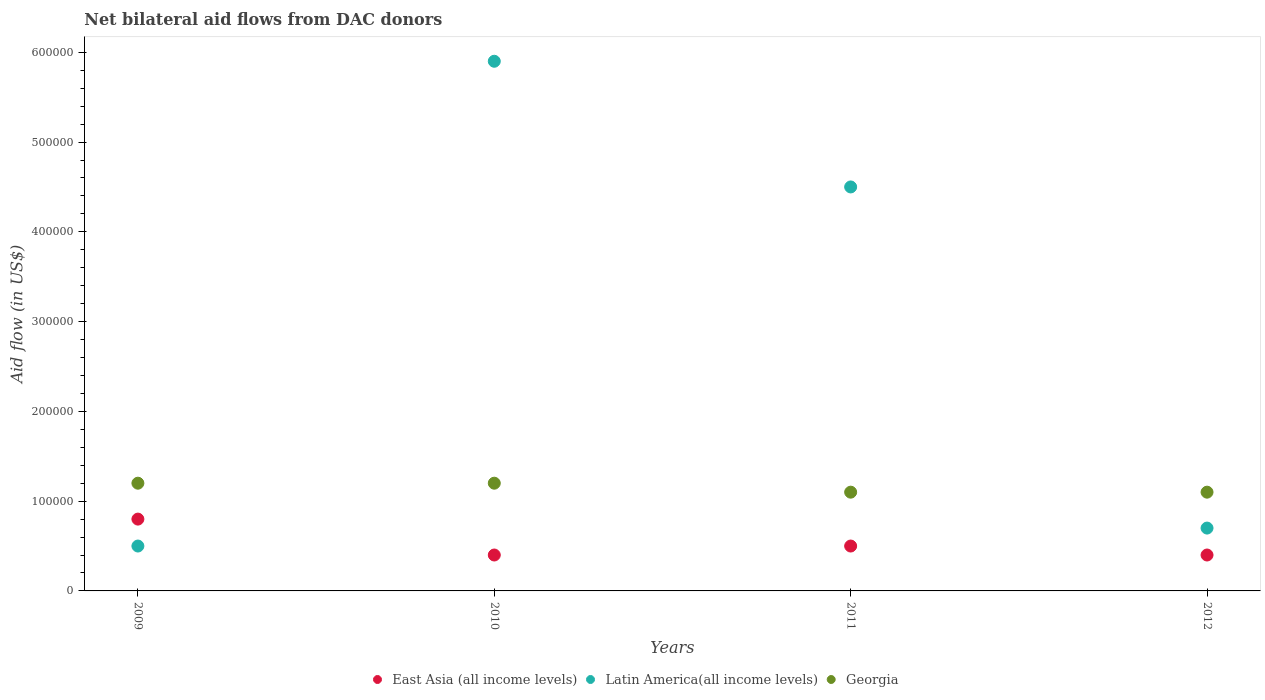What is the net bilateral aid flow in Georgia in 2010?
Give a very brief answer. 1.20e+05. Across all years, what is the maximum net bilateral aid flow in Georgia?
Your answer should be compact. 1.20e+05. Across all years, what is the minimum net bilateral aid flow in East Asia (all income levels)?
Offer a very short reply. 4.00e+04. In which year was the net bilateral aid flow in Latin America(all income levels) minimum?
Offer a very short reply. 2009. What is the total net bilateral aid flow in Latin America(all income levels) in the graph?
Provide a succinct answer. 1.16e+06. What is the difference between the net bilateral aid flow in Georgia in 2010 and that in 2012?
Provide a short and direct response. 10000. What is the difference between the net bilateral aid flow in Georgia in 2009 and the net bilateral aid flow in East Asia (all income levels) in 2010?
Ensure brevity in your answer.  8.00e+04. What is the average net bilateral aid flow in Georgia per year?
Your answer should be very brief. 1.15e+05. In the year 2010, what is the difference between the net bilateral aid flow in East Asia (all income levels) and net bilateral aid flow in Latin America(all income levels)?
Make the answer very short. -5.50e+05. In how many years, is the net bilateral aid flow in Latin America(all income levels) greater than 40000 US$?
Ensure brevity in your answer.  4. Is the net bilateral aid flow in Latin America(all income levels) in 2010 less than that in 2012?
Make the answer very short. No. What is the difference between the highest and the lowest net bilateral aid flow in Georgia?
Make the answer very short. 10000. Does the net bilateral aid flow in East Asia (all income levels) monotonically increase over the years?
Keep it short and to the point. No. Is the net bilateral aid flow in Latin America(all income levels) strictly greater than the net bilateral aid flow in Georgia over the years?
Offer a very short reply. No. Is the net bilateral aid flow in East Asia (all income levels) strictly less than the net bilateral aid flow in Latin America(all income levels) over the years?
Provide a short and direct response. No. How many years are there in the graph?
Provide a succinct answer. 4. What is the difference between two consecutive major ticks on the Y-axis?
Make the answer very short. 1.00e+05. Are the values on the major ticks of Y-axis written in scientific E-notation?
Offer a terse response. No. Does the graph contain any zero values?
Offer a very short reply. No. Does the graph contain grids?
Your answer should be very brief. No. Where does the legend appear in the graph?
Provide a succinct answer. Bottom center. How are the legend labels stacked?
Keep it short and to the point. Horizontal. What is the title of the graph?
Provide a succinct answer. Net bilateral aid flows from DAC donors. Does "Bermuda" appear as one of the legend labels in the graph?
Provide a short and direct response. No. What is the label or title of the Y-axis?
Your answer should be very brief. Aid flow (in US$). What is the Aid flow (in US$) in East Asia (all income levels) in 2009?
Provide a succinct answer. 8.00e+04. What is the Aid flow (in US$) in Latin America(all income levels) in 2009?
Your response must be concise. 5.00e+04. What is the Aid flow (in US$) in Latin America(all income levels) in 2010?
Your response must be concise. 5.90e+05. What is the Aid flow (in US$) of East Asia (all income levels) in 2011?
Give a very brief answer. 5.00e+04. What is the Aid flow (in US$) in Latin America(all income levels) in 2011?
Provide a succinct answer. 4.50e+05. What is the Aid flow (in US$) in East Asia (all income levels) in 2012?
Make the answer very short. 4.00e+04. What is the Aid flow (in US$) of Latin America(all income levels) in 2012?
Your answer should be very brief. 7.00e+04. Across all years, what is the maximum Aid flow (in US$) in Latin America(all income levels)?
Keep it short and to the point. 5.90e+05. What is the total Aid flow (in US$) of Latin America(all income levels) in the graph?
Your response must be concise. 1.16e+06. What is the difference between the Aid flow (in US$) of East Asia (all income levels) in 2009 and that in 2010?
Your answer should be compact. 4.00e+04. What is the difference between the Aid flow (in US$) in Latin America(all income levels) in 2009 and that in 2010?
Your answer should be compact. -5.40e+05. What is the difference between the Aid flow (in US$) of Latin America(all income levels) in 2009 and that in 2011?
Your response must be concise. -4.00e+05. What is the difference between the Aid flow (in US$) of Georgia in 2009 and that in 2011?
Provide a short and direct response. 10000. What is the difference between the Aid flow (in US$) in East Asia (all income levels) in 2009 and that in 2012?
Make the answer very short. 4.00e+04. What is the difference between the Aid flow (in US$) of Latin America(all income levels) in 2009 and that in 2012?
Ensure brevity in your answer.  -2.00e+04. What is the difference between the Aid flow (in US$) in Latin America(all income levels) in 2010 and that in 2011?
Your response must be concise. 1.40e+05. What is the difference between the Aid flow (in US$) in Latin America(all income levels) in 2010 and that in 2012?
Keep it short and to the point. 5.20e+05. What is the difference between the Aid flow (in US$) of Georgia in 2010 and that in 2012?
Give a very brief answer. 10000. What is the difference between the Aid flow (in US$) of East Asia (all income levels) in 2011 and that in 2012?
Offer a terse response. 10000. What is the difference between the Aid flow (in US$) of East Asia (all income levels) in 2009 and the Aid flow (in US$) of Latin America(all income levels) in 2010?
Offer a terse response. -5.10e+05. What is the difference between the Aid flow (in US$) of East Asia (all income levels) in 2009 and the Aid flow (in US$) of Latin America(all income levels) in 2011?
Give a very brief answer. -3.70e+05. What is the difference between the Aid flow (in US$) of East Asia (all income levels) in 2009 and the Aid flow (in US$) of Georgia in 2011?
Make the answer very short. -3.00e+04. What is the difference between the Aid flow (in US$) of East Asia (all income levels) in 2009 and the Aid flow (in US$) of Latin America(all income levels) in 2012?
Ensure brevity in your answer.  10000. What is the difference between the Aid flow (in US$) in East Asia (all income levels) in 2009 and the Aid flow (in US$) in Georgia in 2012?
Give a very brief answer. -3.00e+04. What is the difference between the Aid flow (in US$) of Latin America(all income levels) in 2009 and the Aid flow (in US$) of Georgia in 2012?
Provide a short and direct response. -6.00e+04. What is the difference between the Aid flow (in US$) of East Asia (all income levels) in 2010 and the Aid flow (in US$) of Latin America(all income levels) in 2011?
Give a very brief answer. -4.10e+05. What is the difference between the Aid flow (in US$) of East Asia (all income levels) in 2010 and the Aid flow (in US$) of Georgia in 2011?
Offer a very short reply. -7.00e+04. What is the difference between the Aid flow (in US$) in Latin America(all income levels) in 2010 and the Aid flow (in US$) in Georgia in 2012?
Your answer should be compact. 4.80e+05. What is the difference between the Aid flow (in US$) in East Asia (all income levels) in 2011 and the Aid flow (in US$) in Latin America(all income levels) in 2012?
Ensure brevity in your answer.  -2.00e+04. What is the average Aid flow (in US$) of East Asia (all income levels) per year?
Offer a terse response. 5.25e+04. What is the average Aid flow (in US$) of Georgia per year?
Keep it short and to the point. 1.15e+05. In the year 2010, what is the difference between the Aid flow (in US$) of East Asia (all income levels) and Aid flow (in US$) of Latin America(all income levels)?
Your response must be concise. -5.50e+05. In the year 2010, what is the difference between the Aid flow (in US$) of East Asia (all income levels) and Aid flow (in US$) of Georgia?
Give a very brief answer. -8.00e+04. In the year 2011, what is the difference between the Aid flow (in US$) in East Asia (all income levels) and Aid flow (in US$) in Latin America(all income levels)?
Your answer should be compact. -4.00e+05. In the year 2011, what is the difference between the Aid flow (in US$) in East Asia (all income levels) and Aid flow (in US$) in Georgia?
Provide a succinct answer. -6.00e+04. In the year 2012, what is the difference between the Aid flow (in US$) of East Asia (all income levels) and Aid flow (in US$) of Latin America(all income levels)?
Provide a short and direct response. -3.00e+04. In the year 2012, what is the difference between the Aid flow (in US$) of East Asia (all income levels) and Aid flow (in US$) of Georgia?
Provide a short and direct response. -7.00e+04. In the year 2012, what is the difference between the Aid flow (in US$) of Latin America(all income levels) and Aid flow (in US$) of Georgia?
Provide a short and direct response. -4.00e+04. What is the ratio of the Aid flow (in US$) of East Asia (all income levels) in 2009 to that in 2010?
Give a very brief answer. 2. What is the ratio of the Aid flow (in US$) in Latin America(all income levels) in 2009 to that in 2010?
Keep it short and to the point. 0.08. What is the ratio of the Aid flow (in US$) in East Asia (all income levels) in 2009 to that in 2011?
Your answer should be very brief. 1.6. What is the ratio of the Aid flow (in US$) of Latin America(all income levels) in 2009 to that in 2011?
Your response must be concise. 0.11. What is the ratio of the Aid flow (in US$) in Georgia in 2009 to that in 2011?
Give a very brief answer. 1.09. What is the ratio of the Aid flow (in US$) in Latin America(all income levels) in 2009 to that in 2012?
Make the answer very short. 0.71. What is the ratio of the Aid flow (in US$) in East Asia (all income levels) in 2010 to that in 2011?
Your answer should be compact. 0.8. What is the ratio of the Aid flow (in US$) in Latin America(all income levels) in 2010 to that in 2011?
Your answer should be compact. 1.31. What is the ratio of the Aid flow (in US$) of Latin America(all income levels) in 2010 to that in 2012?
Provide a short and direct response. 8.43. What is the ratio of the Aid flow (in US$) in Georgia in 2010 to that in 2012?
Ensure brevity in your answer.  1.09. What is the ratio of the Aid flow (in US$) of Latin America(all income levels) in 2011 to that in 2012?
Give a very brief answer. 6.43. What is the ratio of the Aid flow (in US$) in Georgia in 2011 to that in 2012?
Provide a short and direct response. 1. What is the difference between the highest and the second highest Aid flow (in US$) of Georgia?
Provide a short and direct response. 0. What is the difference between the highest and the lowest Aid flow (in US$) in East Asia (all income levels)?
Ensure brevity in your answer.  4.00e+04. What is the difference between the highest and the lowest Aid flow (in US$) in Latin America(all income levels)?
Your answer should be compact. 5.40e+05. 